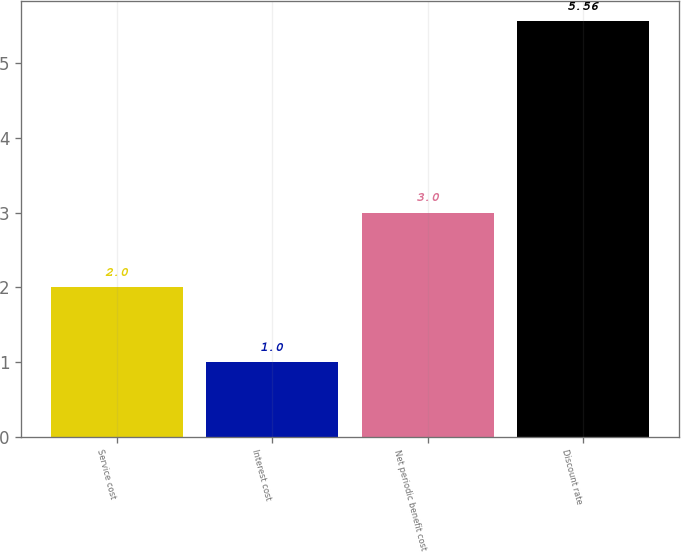Convert chart. <chart><loc_0><loc_0><loc_500><loc_500><bar_chart><fcel>Service cost<fcel>Interest cost<fcel>Net periodic benefit cost<fcel>Discount rate<nl><fcel>2<fcel>1<fcel>3<fcel>5.56<nl></chart> 